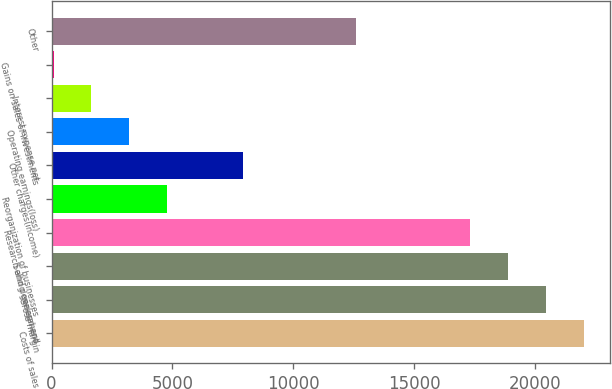<chart> <loc_0><loc_0><loc_500><loc_500><bar_chart><fcel>Costs of sales<fcel>Gross margin<fcel>Selling general and<fcel>Research and development<fcel>Reorganization of businesses<fcel>Other charges(income)<fcel>Operating earnings(loss)<fcel>Interest expense net<fcel>Gains on sales of investments<fcel>Other<nl><fcel>22005<fcel>20439<fcel>18873<fcel>17307<fcel>4779<fcel>7911<fcel>3213<fcel>1647<fcel>81<fcel>12609<nl></chart> 